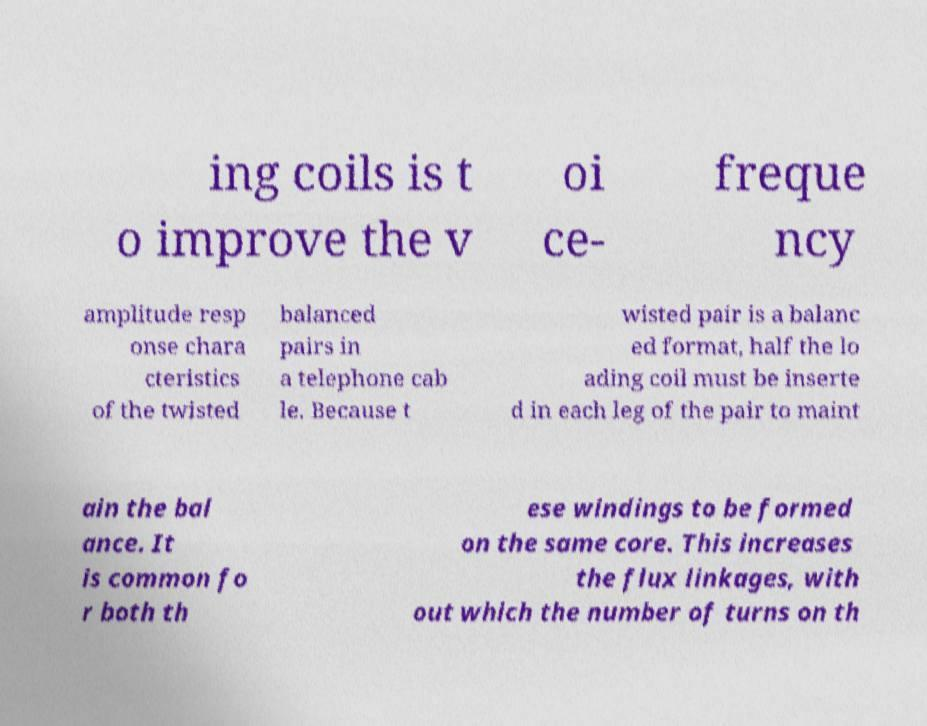Can you read and provide the text displayed in the image?This photo seems to have some interesting text. Can you extract and type it out for me? ing coils is t o improve the v oi ce- freque ncy amplitude resp onse chara cteristics of the twisted balanced pairs in a telephone cab le. Because t wisted pair is a balanc ed format, half the lo ading coil must be inserte d in each leg of the pair to maint ain the bal ance. It is common fo r both th ese windings to be formed on the same core. This increases the flux linkages, with out which the number of turns on th 